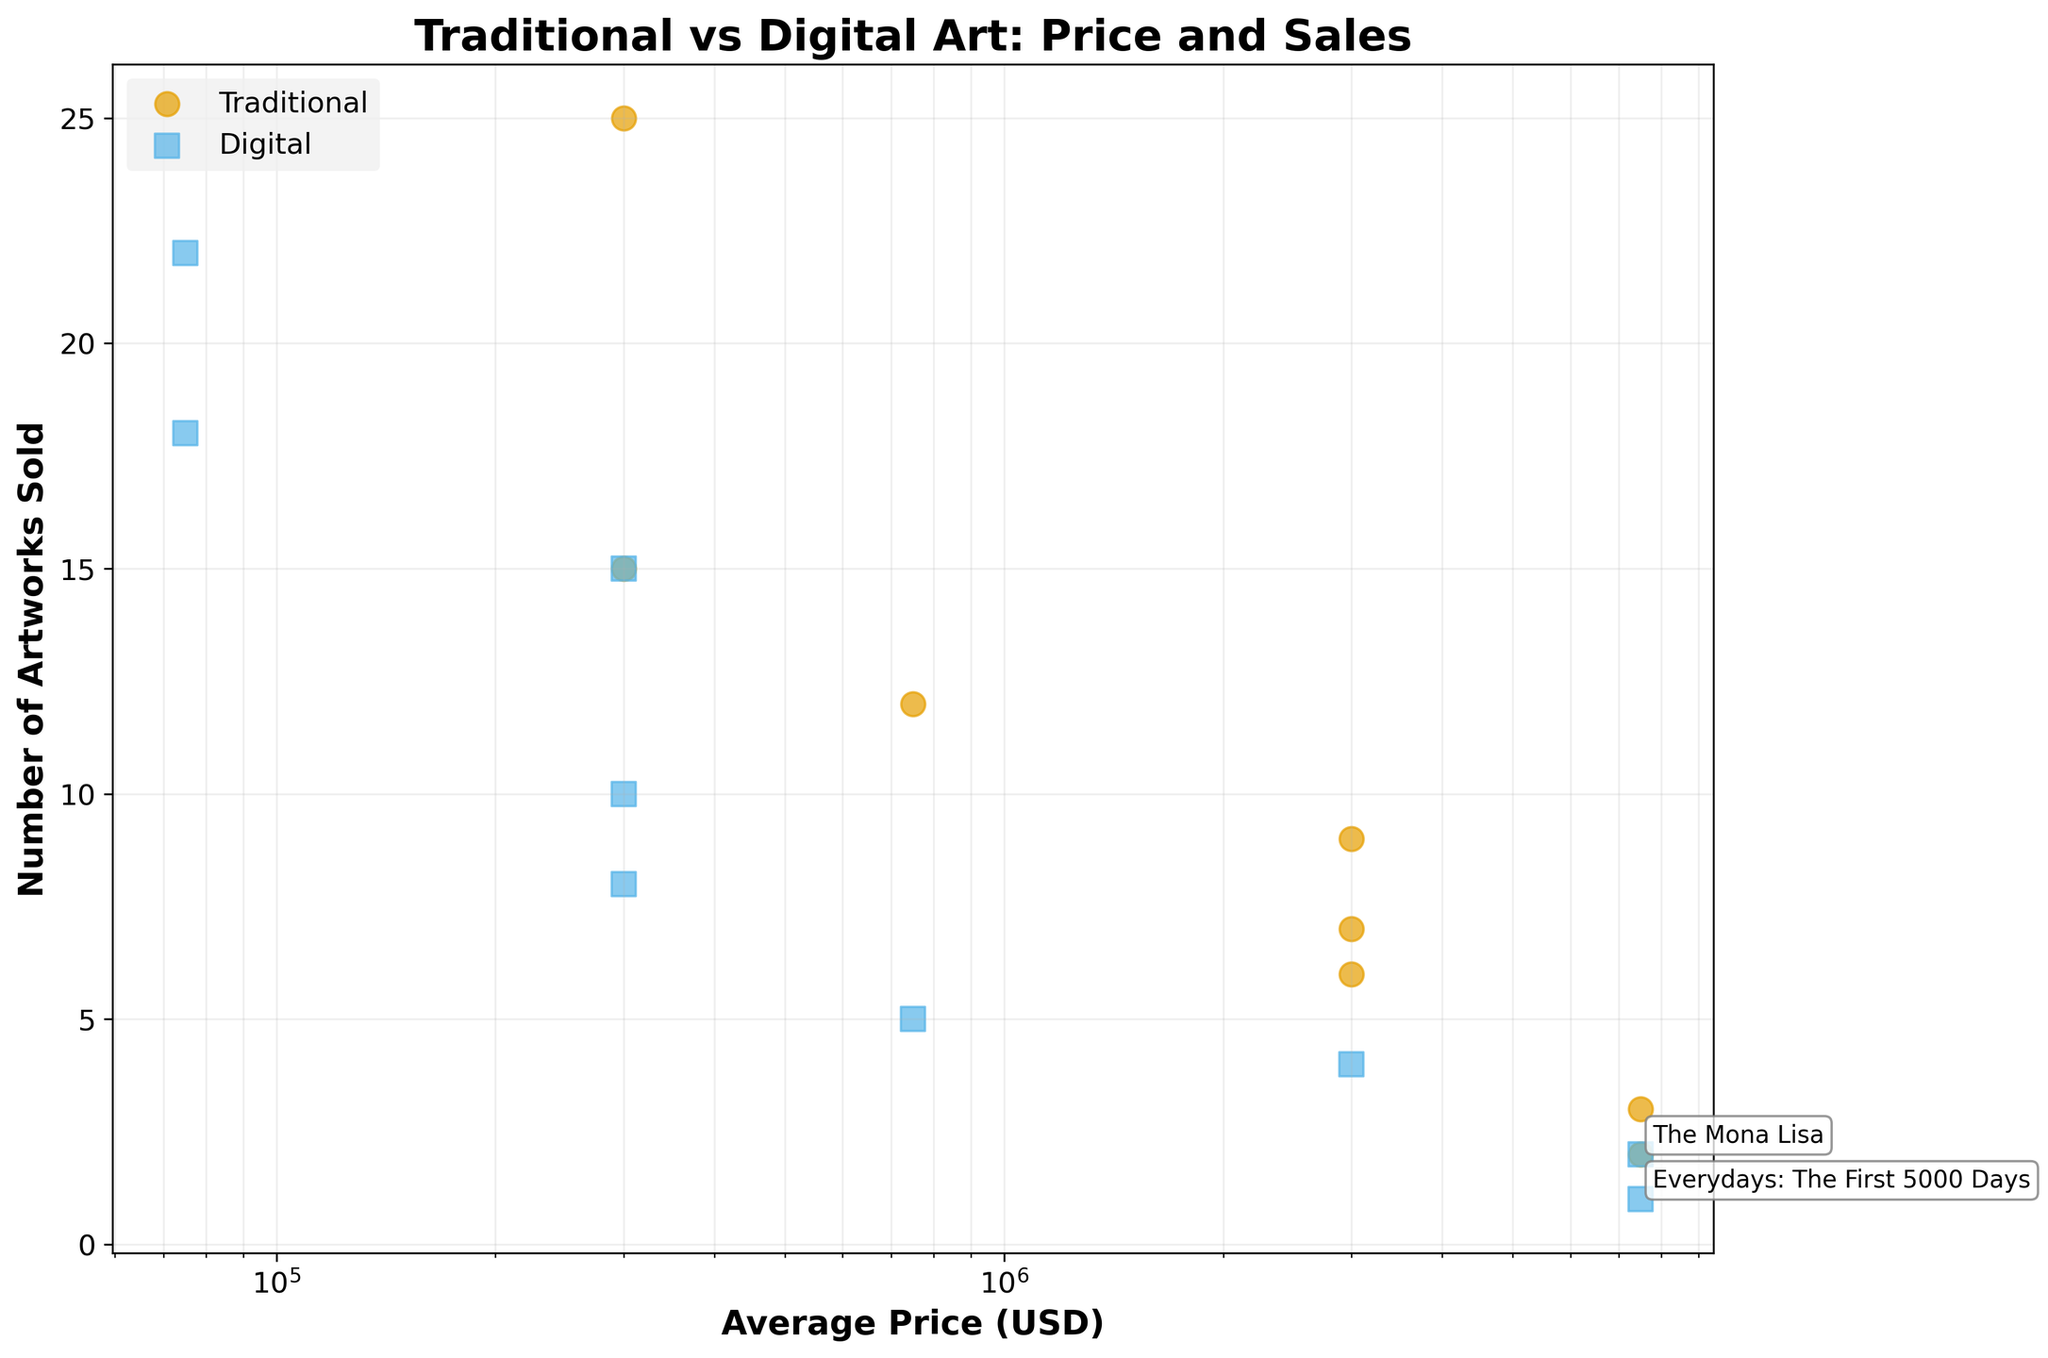What type of artworks sold more than 20 pieces in a single year? To determine which type of artworks sold more than 20 pieces, we need to look for data points with a y-value (Number of Artworks Sold) greater than 20. The only data points exceeding this threshold belong to Digital artworks in the years 2020 and 2021.
Answer: Digital What is the average price range of "Everydays: The First 5000 Days"? "Everydays: The First 5000 Days" is annotated on the plot, and its position on the x-axis is in the "5000000 - 10000000" range. The average of this range is calculated as (5000000 + 10000000) / 2.
Answer: 7500000 Which year had the highest number of artworks sold for traditional pieces priced between 1000000 and 5000000 USD? Filter the dataset to traditional artworks with an average price between 1000000 and 5000000 USD, and compare the number of pieces sold in each year. For 2020, there is "The Starry Night" with 7 pieces. For 2021, there is "Girl with a Pearl Earring" with 9 pieces, and for 2022 there is "Liberty Leading the People" with 6 pieces. The year with the highest number is 2021.
Answer: 2021 How does the price range affect the number of artworks sold for traditional art compared to digital art? Look at the trend in the scatter plot for both Traditional and Digital categories. Generally, for Traditional art, higher-priced ranges have fewer pieces sold, while Digital art exhibits significant sales even in lower price ranges. This suggests a less steep price sensitivity for Digital art.
Answer: Traditional: Higher prices mean fewer sales, Digital: High sales in lower price ranges Which artwork had the lowest number of pieces sold and what type of art was it? By identifying the lowest y-value on the plot and checking the corresponding x-value type, we see the artwork with the lowest number of pieces sold is "Everydays: The First 5000 Days" and it is a Digital artwork.
Answer: Everydays: The First 5000 Days, Digital How do the number of artworks sold for "The Mona Lisa" and "Everydays: The First 5000 Days" compare? "The Mona Lisa" is annotated on the plot with a y-value of 2, while "Everydays: The First 5000 Days" is annotated with a y-value of 1. Comparing these values shows that "The Mona Lisa" sold more.
Answer: The Mona Lisa sold more What is the total number of traditional artworks sold in 2022? Summing up the number of traditional artworks sold in 2022: "Liberty Leading the People" (6), "The Scream" (12), and "American Gothic" (25). Adding these gives 6 + 12 + 25.
Answer: 43 How do the top-selling digital and traditional artworks compare in terms of the number of pieces sold? On the plot, the top-selling digital artwork (highest y-value) appears to be "Not Forgotten" (22 pieces). The top-selling traditional artwork is "American Gothic" (25 pieces). Comparing these values, "American Gothic" sold more.
Answer: American Gothic sold more 